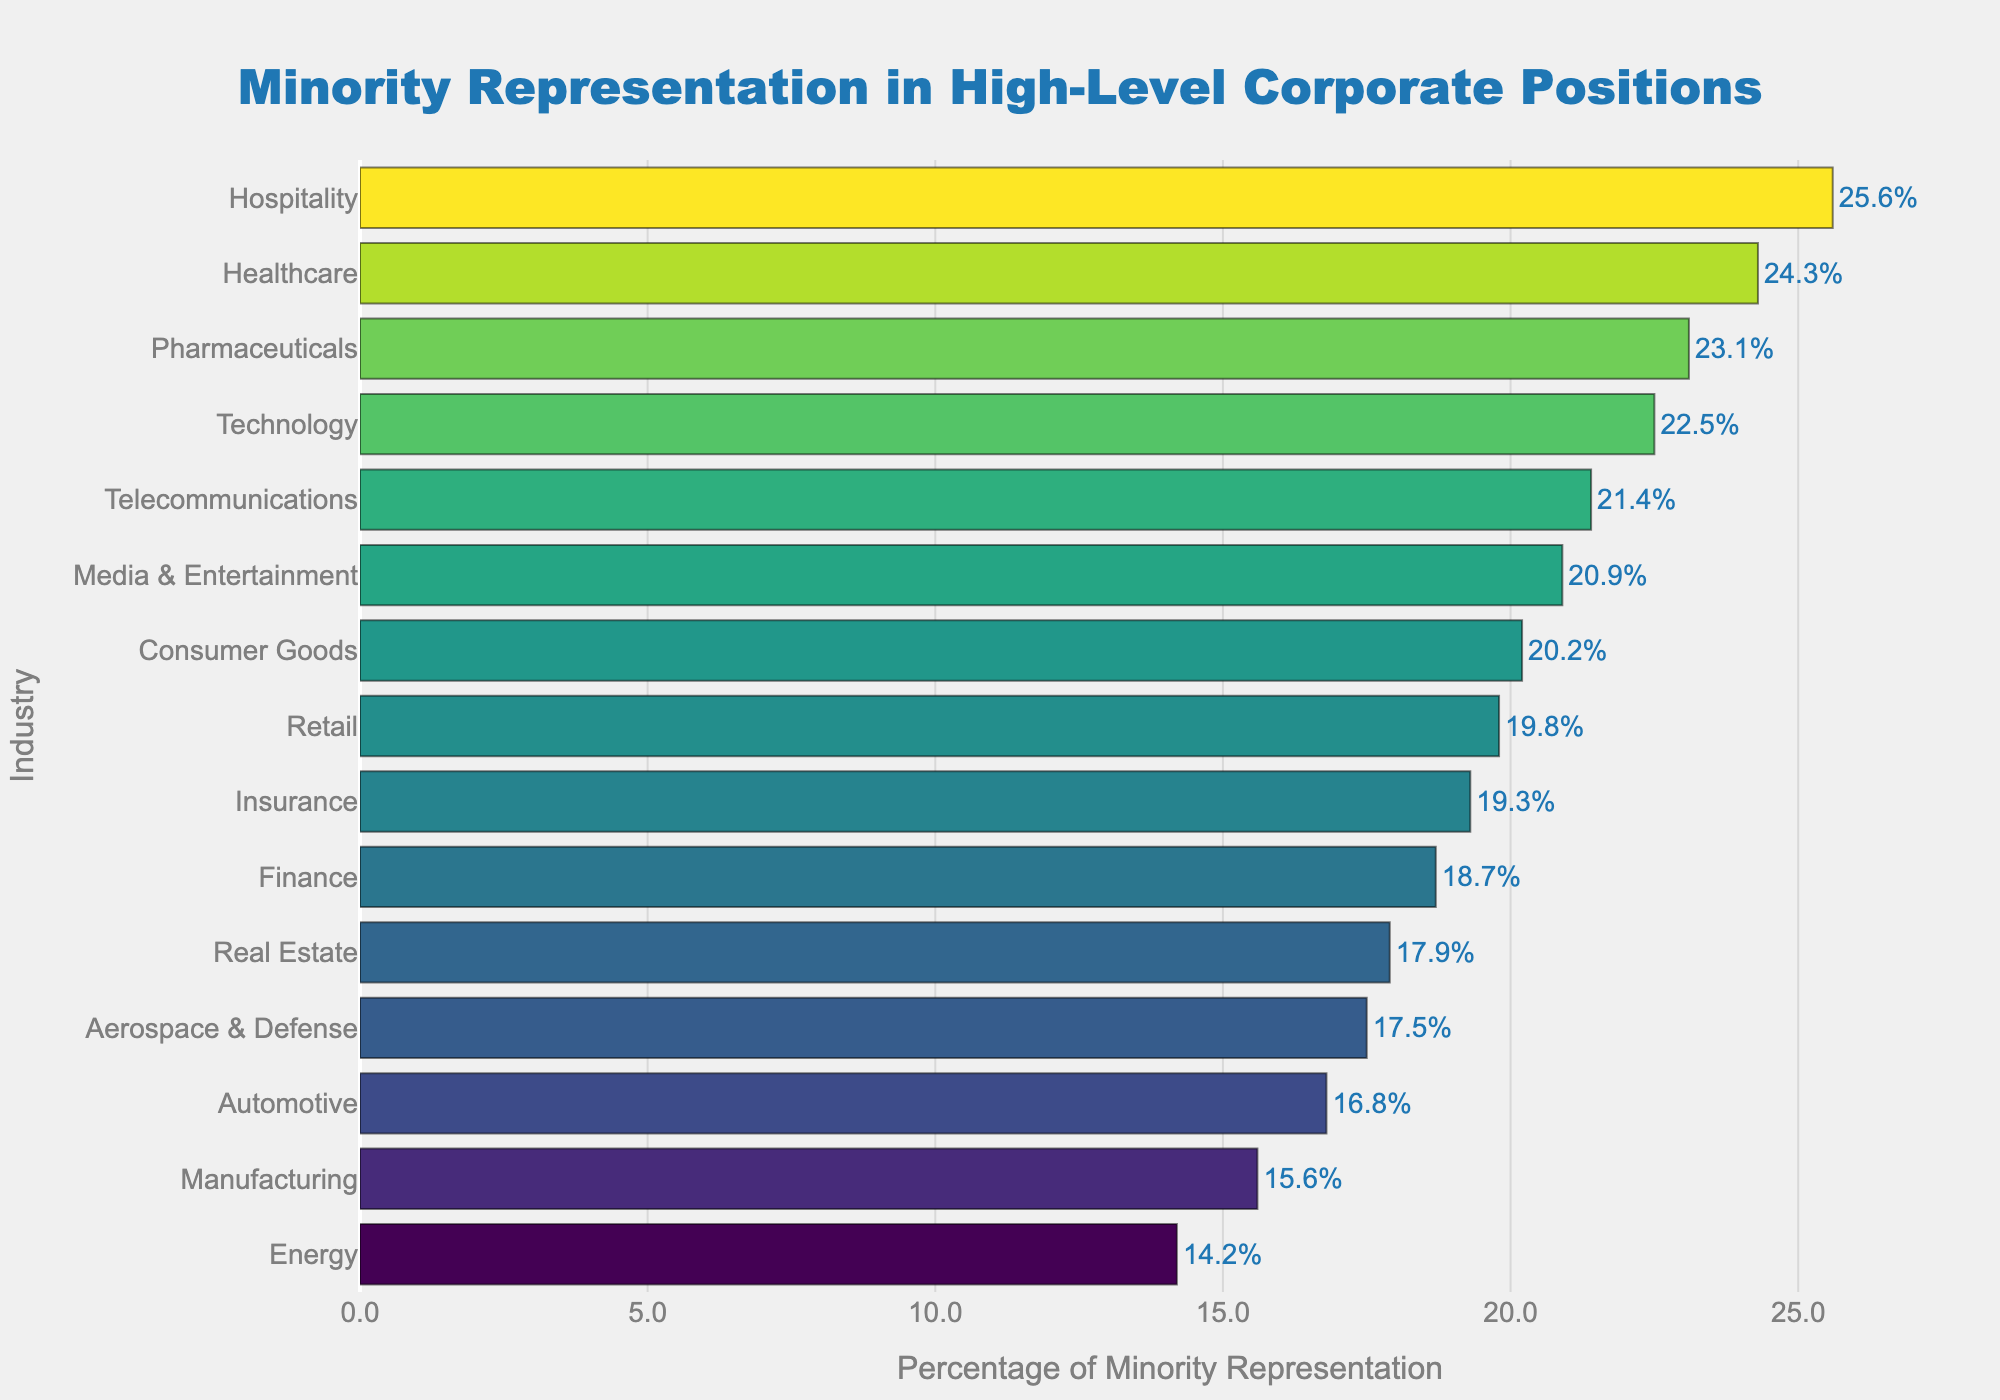Which industry has the highest percentage of minority representation? Look for the bar that is the longest or the highest value on the horizontal axis.
Answer: Hospitality Compare the minority representations in the Technology and Manufacturing industries. Which one is higher and by how much? Find the percentage of minority representation in Technology (22.5%) and Manufacturing (15.6%), then subtract the smaller value from the larger value.
Answer: Technology by 6.9% Which industry has the lowest percentage of minority representation? Identify the bar with the shortest length or the lowest value on the horizontal axis.
Answer: Energy How many industries have a minority representation percentage greater than 20%? Count the bars that extend beyond the 20% mark on the horizontal axis.
Answer: 7 Which industries have a minority representation percentage close to the median value among all industries? First, find the median percentage of the ordered values. Then identify industries with percentages closest to this value. Median of (14.2, 15.6, 16.8, 17.5, 17.9, 18.7, 19.3, 19.8, 20.2, 20.9, 21.4, 22.5, 23.1, 24.3, 25.6) is 19.8% (Retail).
Answer: Retail and Consumer Goods Which industries are within 5% range from the highest percentage of minority representation? Identify industries between 20.6% (25.6% - 5%) and 25.6%.
Answer: Technology, Healthcare, Media & Entertainment, Telecommunications, Pharmaceuticals, Hospitality How much lower is minority representation in Manufacturing compared to Healthcare? Subtract the percentage in Manufacturing (15.6%) from Healthcare (24.3%).
Answer: 8.7% 